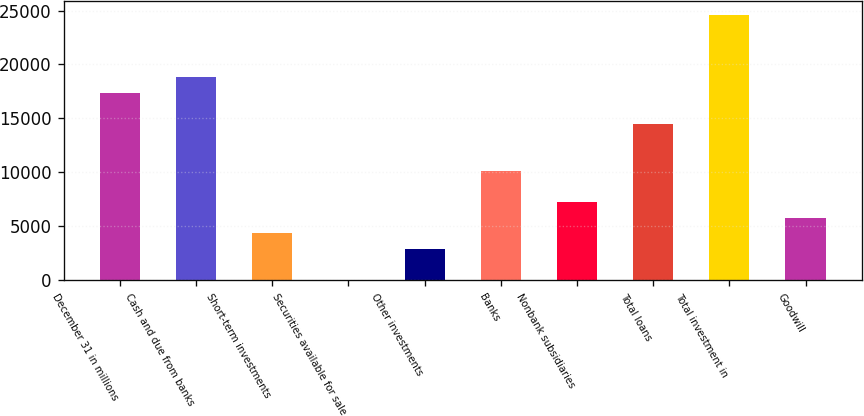Convert chart to OTSL. <chart><loc_0><loc_0><loc_500><loc_500><bar_chart><fcel>December 31 in millions<fcel>Cash and due from banks<fcel>Short-term investments<fcel>Securities available for sale<fcel>Other investments<fcel>Banks<fcel>Nonbank subsidiaries<fcel>Total loans<fcel>Total investment in<fcel>Goodwill<nl><fcel>17387.2<fcel>18835.3<fcel>4354.3<fcel>10<fcel>2906.2<fcel>10146.7<fcel>7250.5<fcel>14491<fcel>24627.7<fcel>5802.4<nl></chart> 